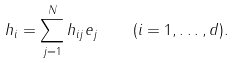Convert formula to latex. <formula><loc_0><loc_0><loc_500><loc_500>h _ { i } = \sum _ { j = 1 } ^ { N } h _ { i j } e _ { j } \quad ( i = 1 , \dots , d ) .</formula> 